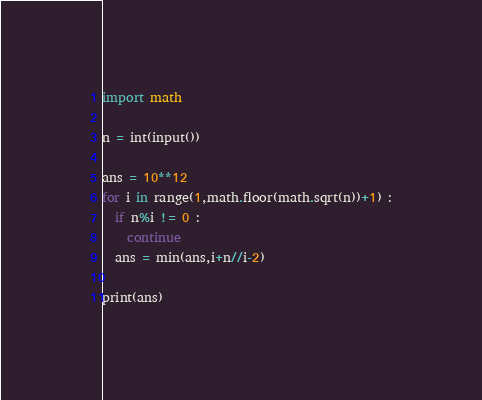<code> <loc_0><loc_0><loc_500><loc_500><_Python_>import math

n = int(input())

ans = 10**12
for i in range(1,math.floor(math.sqrt(n))+1) :
  if n%i != 0 :
    continue
  ans = min(ans,i+n//i-2)

print(ans)</code> 